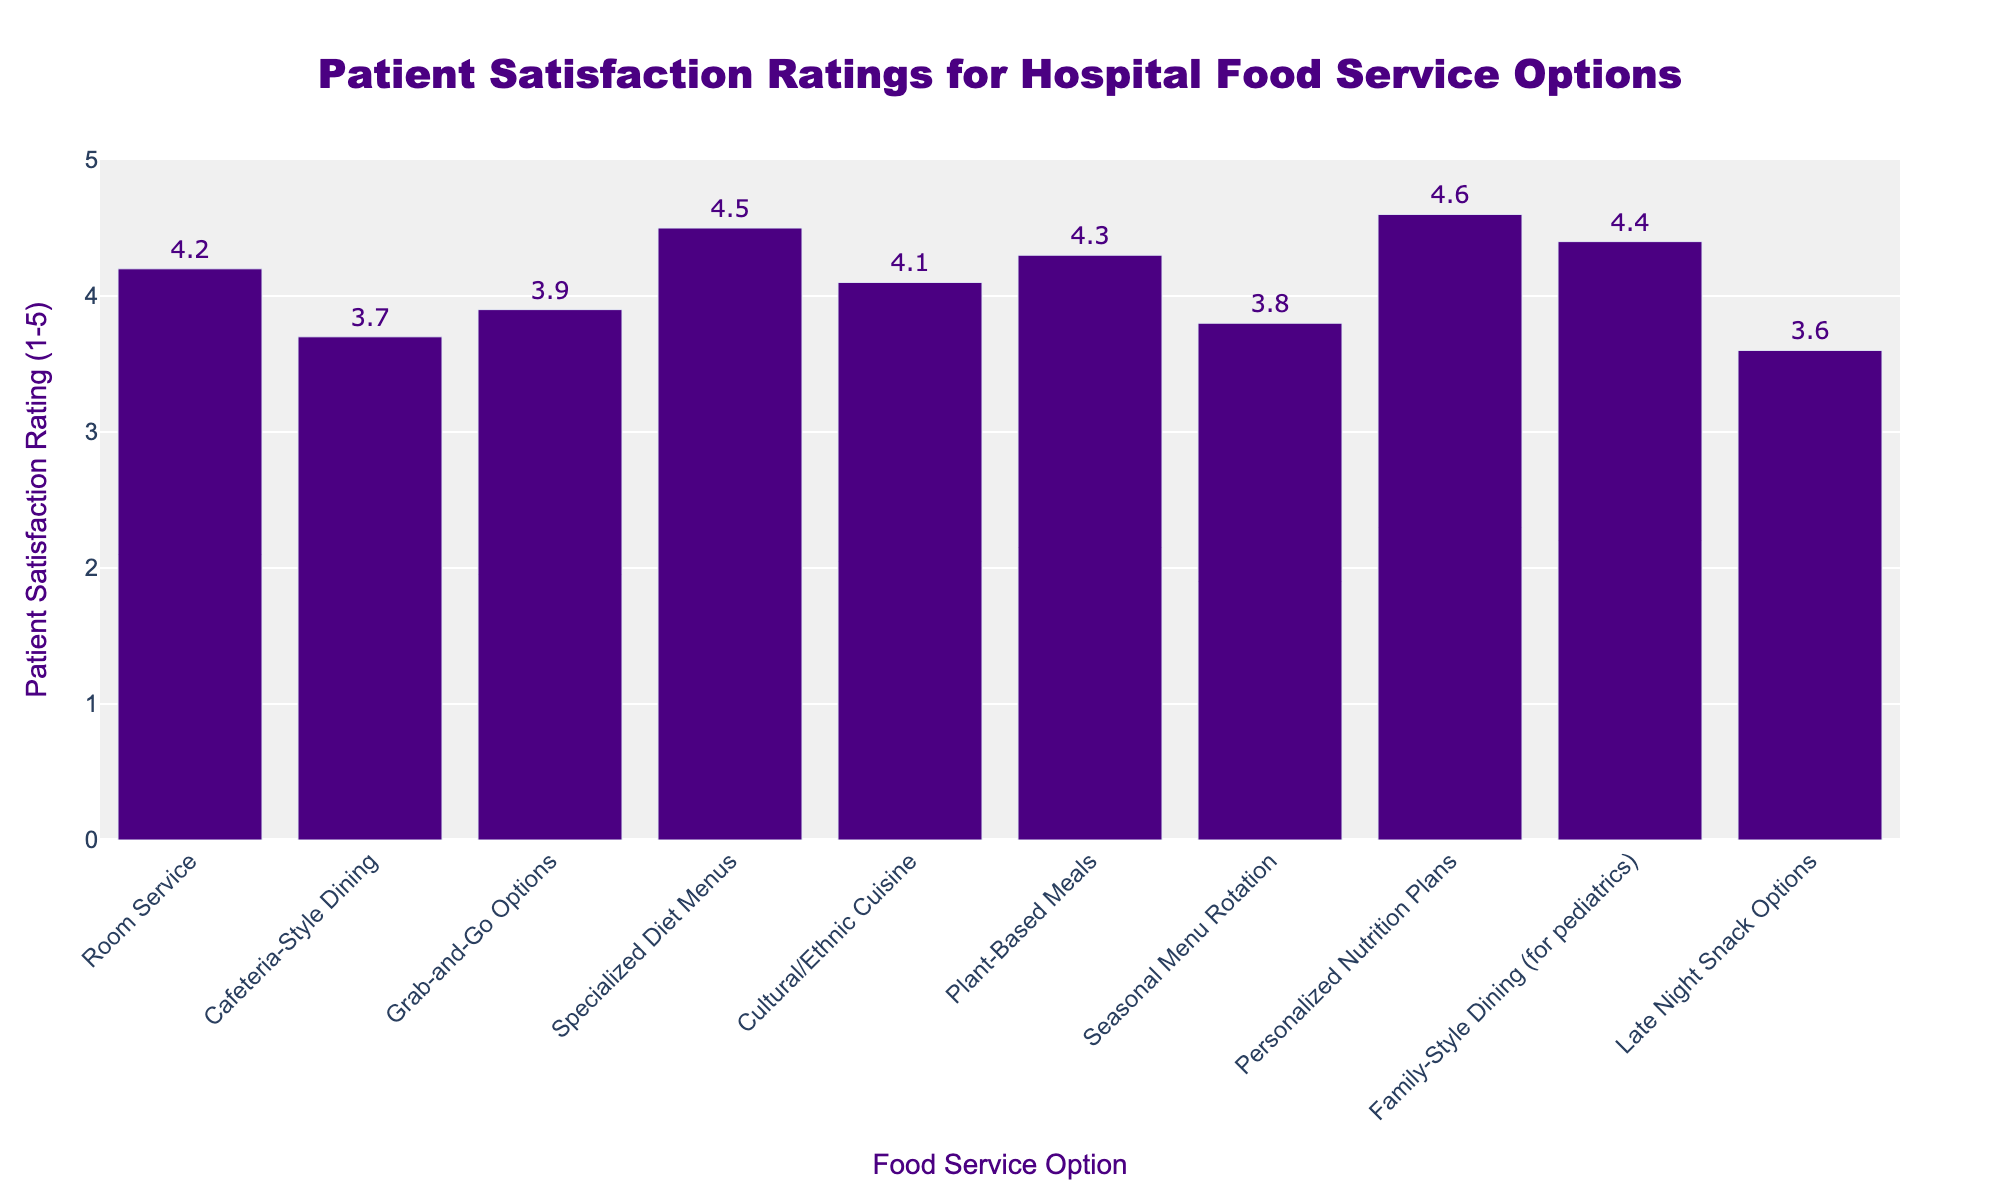What is the highest patient satisfaction rating? The highest bar on the chart corresponds to the "Personalized Nutrition Plans" option, with a rating of 4.6.
Answer: 4.6 Which food service option has the lowest patient satisfaction rating? The lowest bar on the chart corresponds to the "Late Night Snack Options" with a rating of 3.6.
Answer: Late Night Snack Options How much higher is the satisfaction rating for "Personalized Nutrition Plans" compared to "Cafeteria-Style Dining"? The satisfaction rating for "Personalized Nutrition Plans" is 4.6 and for "Cafeteria-Style Dining" is 3.7. Subtracting these gives 4.6 - 3.7 = 0.9.
Answer: 0.9 Which food service options have a satisfaction rating of 4.5 or above? The bars for "Specialized Diet Menus" (4.5), "Personalized Nutrition Plans" (4.6), and "Family-Style Dining (for pediatrics)" (4.4) are above or equal to 4.5.
Answer: Specialized Diet Menus, Personalized Nutrition Plans, Family-Style Dining (for pediatrics) How many food service options have a patient satisfaction rating of 4.0 or higher? Count the bars that are at 4.0 or higher: Room Service (4.2), Specialized Diet Menus (4.5), Cultural/Ethnic Cuisine (4.1), Plant-Based Meals (4.3), Personalized Nutrition Plans (4.6), Family-Style Dining (for pediatrics) (4.4). There are 6 options.
Answer: 6 What is the average satisfaction rating across all food service options? The sum of ratings is 4.2 + 3.7 + 3.9 + 4.5 + 4.1 + 4.3 + 3.8 + 4.6 + 4.4 + 3.6 = 41.1. There are 10 options, so the average is 41.1 / 10 = 4.11.
Answer: 4.11 Which food service option has a satisfaction rating closest to the mean rating? The average rating is 4.11, and the closest values are Room Service (4.2) and Cultural/Ethnic Cuisine (4.1). The difference is 0.09 and 0.01, respectively. "Cultural/Ethnic Cuisine" is closest.
Answer: Cultural/Ethnic Cuisine Are there more food service options with a satisfaction rating above 4.0 or below 4.0? There are 6 options with a rating above 4.0 (Room Service, Specialized Diet Menus, Cultural/Ethnic Cuisine, Plant-Based Meals, Personalized Nutrition Plans, Family-Style Dining) and 4 options below 4.0 (Cafeteria-Style Dining, Grab-and-Go Options, Seasonal Menu Rotation, Late Night Snack Options). There are more options above 4.0.
Answer: Above 4.0 Which visual attribute indicates the patient satisfaction rating for each food service option? The height of the bars indicates the patient satisfaction rating, with higher bars corresponding to higher ratings.
Answer: Height of the bars 